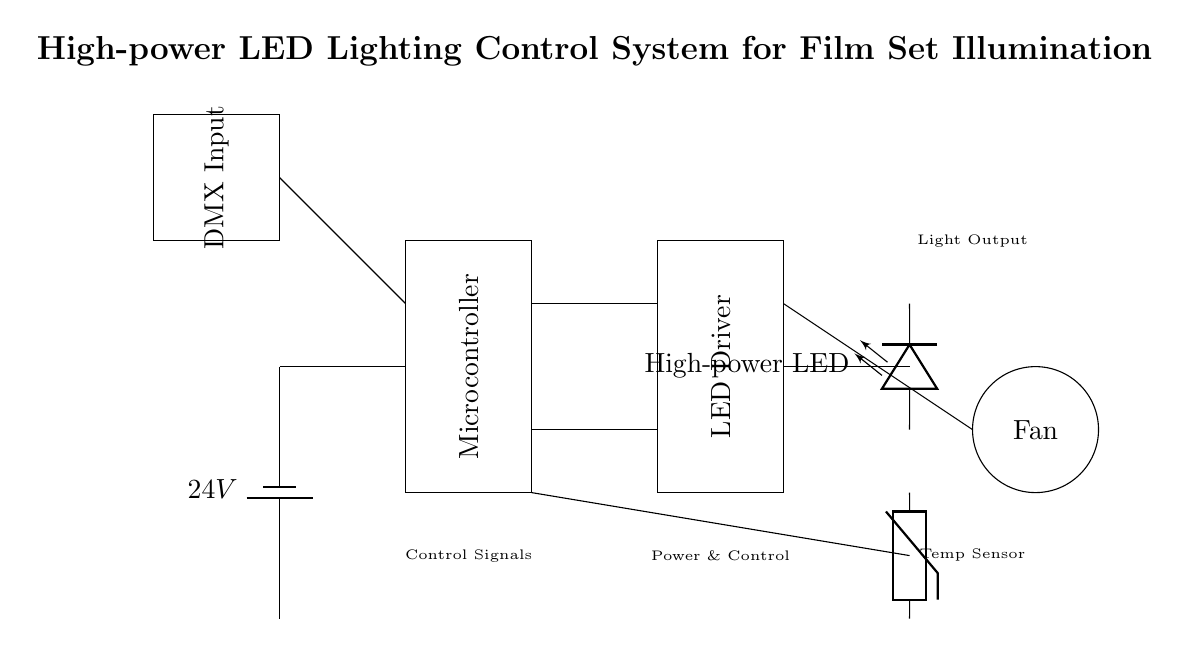What is the power supply voltage for this circuit? The power supply is labeled as 24V, which directly indicates the voltage provided.
Answer: 24V What component is used to control the illumination? The microcontroller component is specifically included in the diagram to manage the control signals for illumination.
Answer: Microcontroller How many main components are displayed in the circuit? The diagram shows a total of four main components: the battery, microcontroller, LED driver, and high-power LED.
Answer: Four What is the purpose of the DMX input in this setup? The DMX input is used for control signal input, allowing for external lighting control, particularly in film and stage environments.
Answer: Control signal interface What is the function of the temperature sensor in this circuit? The temperature sensor is used to monitor the temperature of the LED or surrounding components to ensure safe operation, and it connects to the microcontroller for processing.
Answer: Monitor temperature Where does the cooling fan receive its power from? The cooling fan is connected to the LED driver, which indicates it receives power through that connection to maintain safe operating temperatures.
Answer: LED driver 